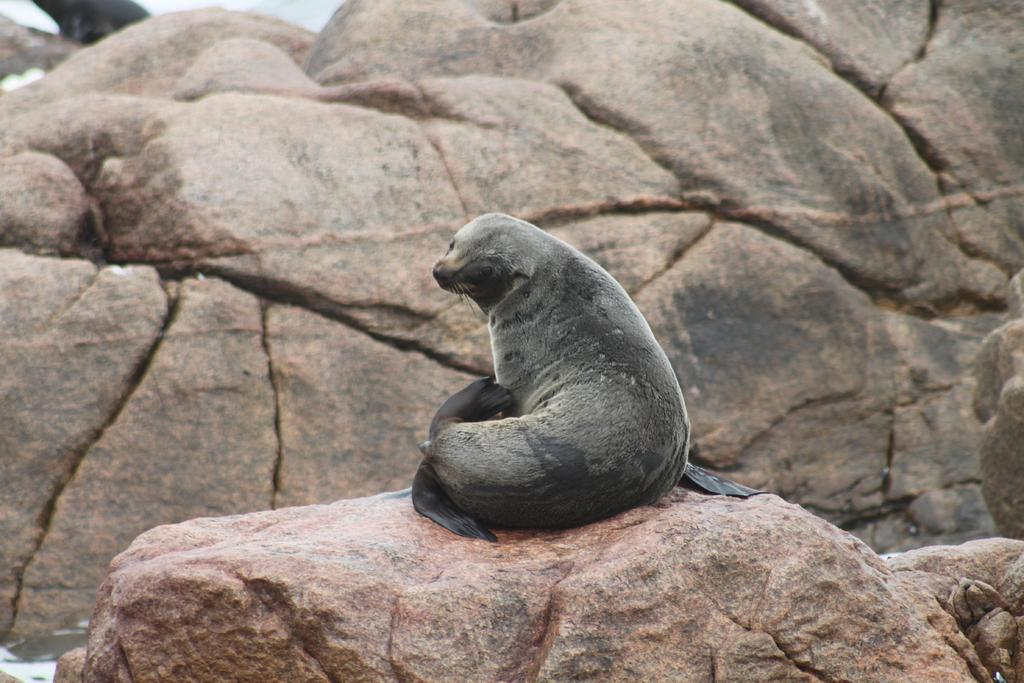What type of animal is in the image? There is a sea lion in the image. Where is the sea lion located? The sea lion is on a rock. What type of train can be seen in the image? There is no train present in the image; it features a sea lion on a rock. What type of bait is the sea lion using to catch fish in the image? There is no fishing activity depicted in the image, and the sea lion is not using any bait. 